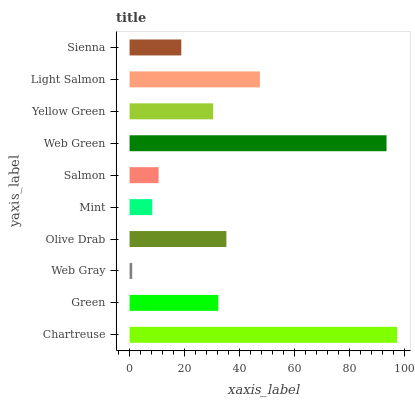Is Web Gray the minimum?
Answer yes or no. Yes. Is Chartreuse the maximum?
Answer yes or no. Yes. Is Green the minimum?
Answer yes or no. No. Is Green the maximum?
Answer yes or no. No. Is Chartreuse greater than Green?
Answer yes or no. Yes. Is Green less than Chartreuse?
Answer yes or no. Yes. Is Green greater than Chartreuse?
Answer yes or no. No. Is Chartreuse less than Green?
Answer yes or no. No. Is Green the high median?
Answer yes or no. Yes. Is Yellow Green the low median?
Answer yes or no. Yes. Is Salmon the high median?
Answer yes or no. No. Is Chartreuse the low median?
Answer yes or no. No. 